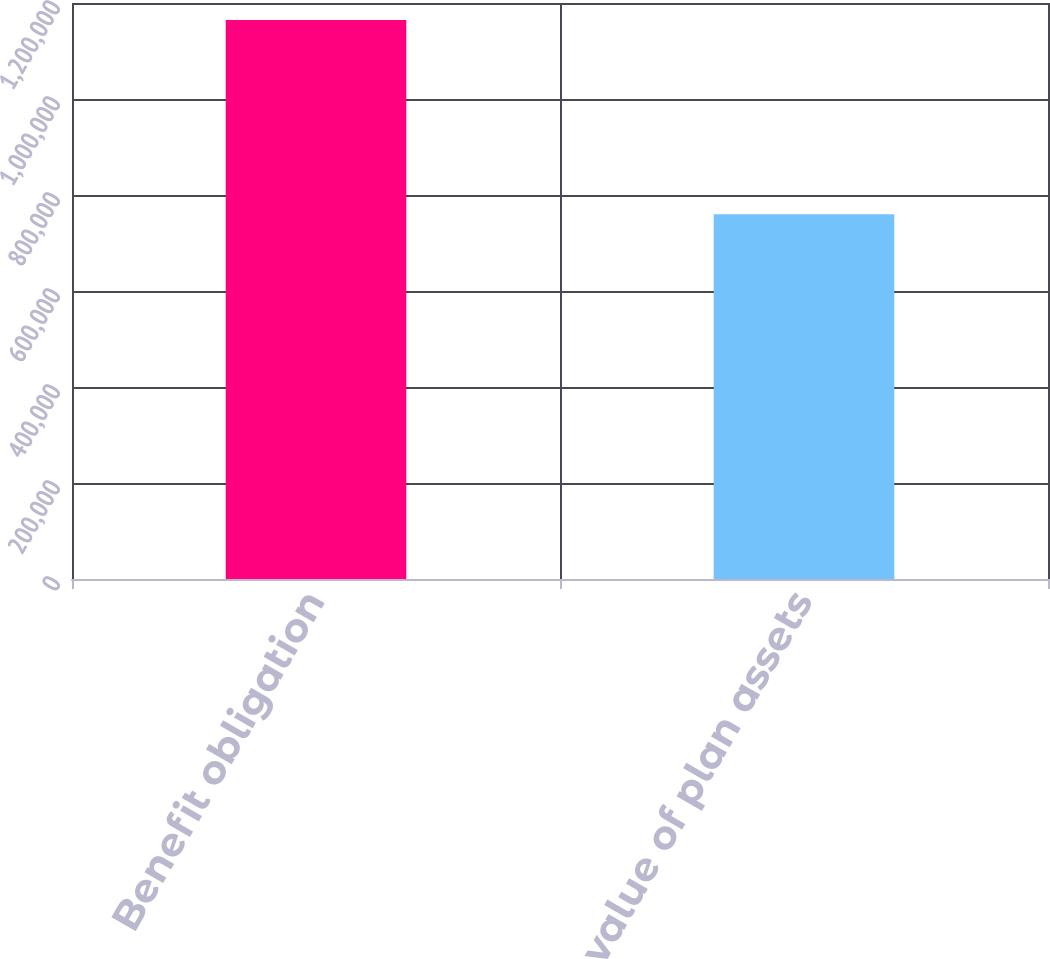Convert chart to OTSL. <chart><loc_0><loc_0><loc_500><loc_500><bar_chart><fcel>Benefit obligation<fcel>Fair value of plan assets<nl><fcel>1.16452e+06<fcel>760155<nl></chart> 